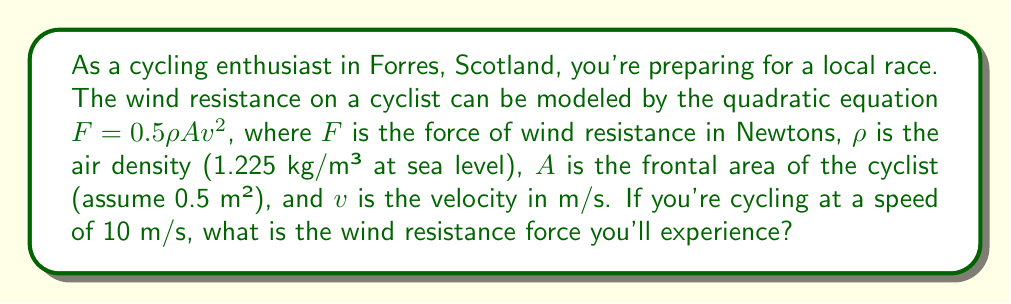Could you help me with this problem? Let's solve this step-by-step:

1. We're given the quadratic equation for wind resistance:
   $$F = 0.5\rho Av^2$$

2. We know the following values:
   - $\rho$ (air density) = 1.225 kg/m³
   - $A$ (frontal area) = 0.5 m²
   - $v$ (velocity) = 10 m/s

3. Let's substitute these values into the equation:
   $$F = 0.5 \times 1.225 \times 0.5 \times 10^2$$

4. Simplify the calculation:
   $$F = 0.5 \times 1.225 \times 0.5 \times 100$$
   $$F = 0.30625 \times 100$$
   $$F = 30.625$$

5. Round to two decimal places:
   $$F \approx 30.63\text{ N}$$

Therefore, the wind resistance force experienced while cycling at 10 m/s is approximately 30.63 Newtons.
Answer: 30.63 N 